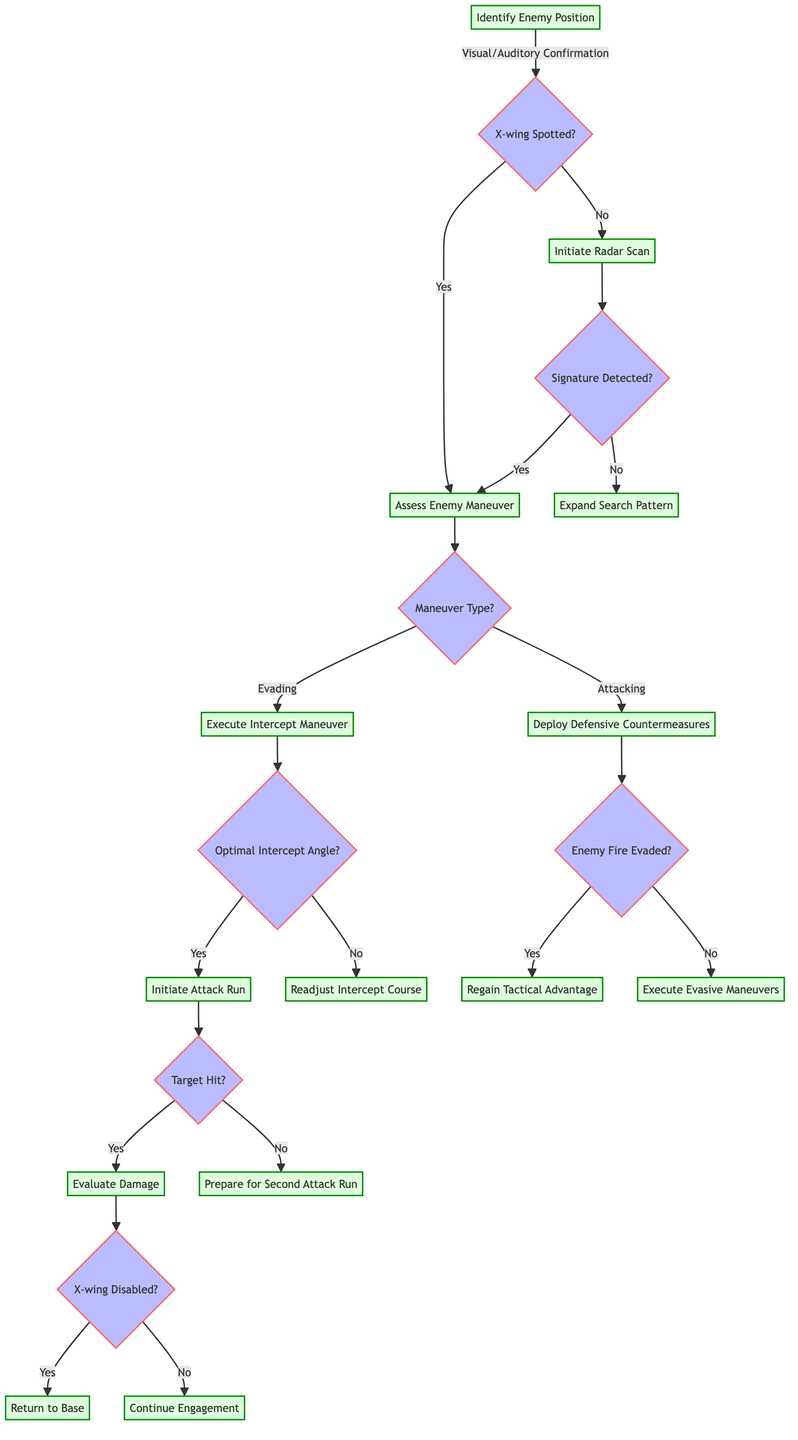What is the first step in the flow chart? The first step in the flow chart is "Identify Enemy Position", which is indicated at the top of the diagram as the initial action to take in the dogfight.
Answer: Identify Enemy Position What decision follows after identifying the enemy position? After identifying the enemy position, the next decision point is "X-wing Spotted?" which determines the subsequent action based on whether the X-wing is visually confirmed.
Answer: X-wing Spotted? How many actions can be taken after determining that the X-wing is spotted? There are two actions that can be taken; they are "Assess Enemy Maneuver" if the X-wing is spotted and "Initiate Radar Scan" if it is not.
Answer: Two actions If the radar scan does not detect a signature, what action is taken next? If no signature is found after initiating a radar scan, the next action is to "Expand Search Pattern", as indicated in the outcomes of the radar scan decision point.
Answer: Expand Search Pattern What happens if the X-wing is identified as evading? If the X-wing is identified as evading, the next step is to "Execute Intercept Maneuver" based on the assessment of the enemy maneuver.
Answer: Execute Intercept Maneuver What decision is made after executing an intercept maneuver? After executing an intercept maneuver, the decision made is whether "Optimal Intercept Angle Achieved" before proceeding to the next action.
Answer: Optimal Intercept Angle Achieved If the target is missed during the attack run, what should the pilot prepare for? If the target is missed, the next action is to "Prepare for Second Attack Run" as indicated in the outcomes following the attack run decision.
Answer: Prepare for Second Attack Run How does the pilot regain tactical advantage? The pilot can regain tactical advantage after successful evasion of enemy fire by following the outcome from the defensive countermeasures step.
Answer: Regain Tactical Advantage What is the final assessment made after the damage evaluation? The final assessment made after evaluating damage is whether the "X-wing Disabled", determining whether to "Return to Base" or "Continue Engagement".
Answer: X-wing Disabled 